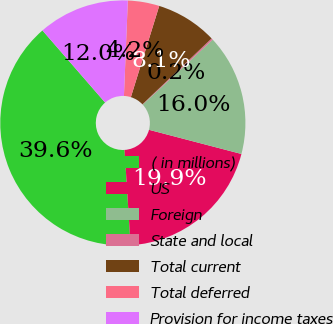Convert chart. <chart><loc_0><loc_0><loc_500><loc_500><pie_chart><fcel>( in millions)<fcel>US<fcel>Foreign<fcel>State and local<fcel>Total current<fcel>Total deferred<fcel>Provision for income taxes<nl><fcel>39.62%<fcel>19.92%<fcel>15.97%<fcel>0.21%<fcel>8.09%<fcel>4.15%<fcel>12.03%<nl></chart> 